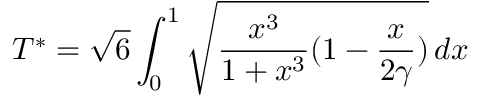<formula> <loc_0><loc_0><loc_500><loc_500>T ^ { * } = \sqrt { 6 } \int _ { 0 } ^ { 1 } \sqrt { \frac { x ^ { 3 } } { 1 + x ^ { 3 } } ( 1 - \frac { x } { 2 \gamma } ) } \, d x</formula> 